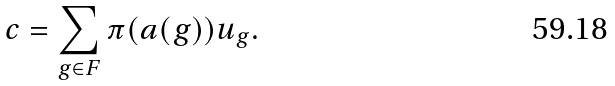Convert formula to latex. <formula><loc_0><loc_0><loc_500><loc_500>c = \sum _ { g \in F } \pi ( a ( g ) ) u _ { g } .</formula> 